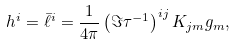Convert formula to latex. <formula><loc_0><loc_0><loc_500><loc_500>h ^ { i } = \bar { \ell } ^ { i } = \frac { 1 } { 4 \pi } \left ( \Im \tau ^ { - 1 } \right ) ^ { i j } K _ { j m } g _ { m } ,</formula> 